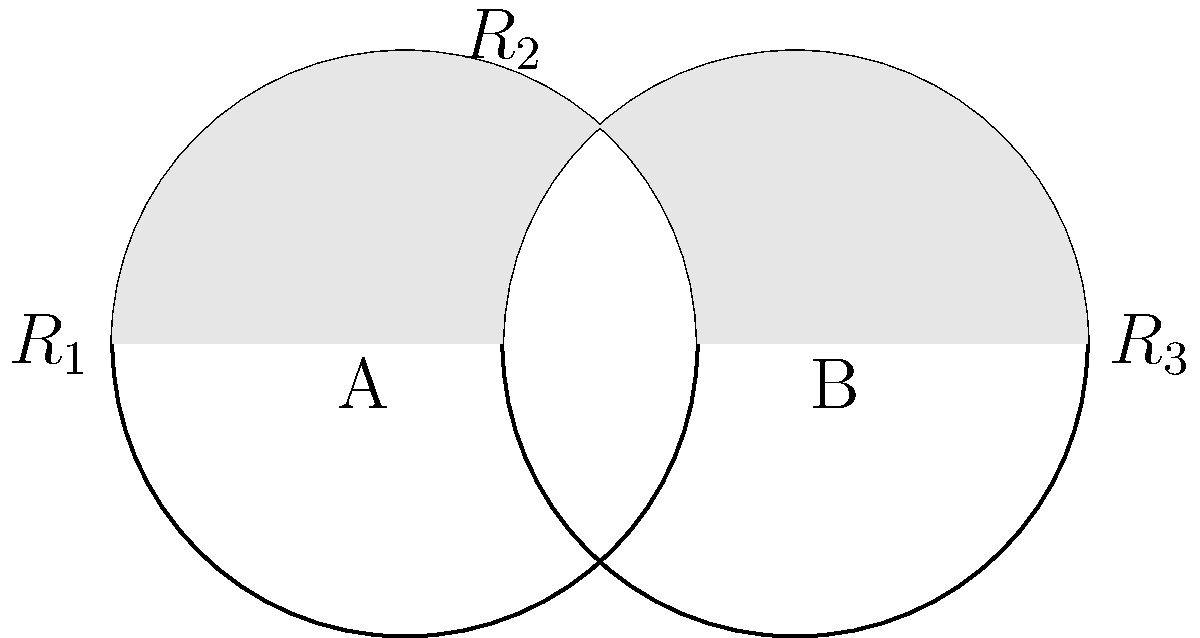In your latest book review, you've decided to use a Venn diagram-like representation to illustrate the overlap between two novels' themes. The diagram shows two intersecting circles, each representing a book. If the total area of both circles is 42π square units, and the area of the non-overlapping region ($R_1 + R_3$) is 30π square units, what fraction of the total area is occupied by the overlapping region ($R_2$)? Let's approach this step-by-step:

1) First, let's define our variables:
   - Let $A_T$ be the total area of both circles
   - Let $A_O$ be the area of the overlapping region ($R_2$)
   - Let $A_N$ be the area of the non-overlapping regions ($R_1 + R_3$)

2) We're given that:
   $A_T = 42\pi$ square units
   $A_N = 30\pi$ square units

3) We know that the total area is the sum of the overlapping and non-overlapping areas:
   $A_T = A_O + A_N$

4) We can substitute the known values:
   $42\pi = A_O + 30\pi$

5) Solving for $A_O$:
   $A_O = 42\pi - 30\pi = 12\pi$ square units

6) To find the fraction of the total area occupied by the overlapping region, we divide $A_O$ by $A_T$:
   $\frac{A_O}{A_T} = \frac{12\pi}{42\pi} = \frac{12}{42} = \frac{2}{7}$

Therefore, the overlapping region occupies $\frac{2}{7}$ of the total area.
Answer: $\frac{2}{7}$ 